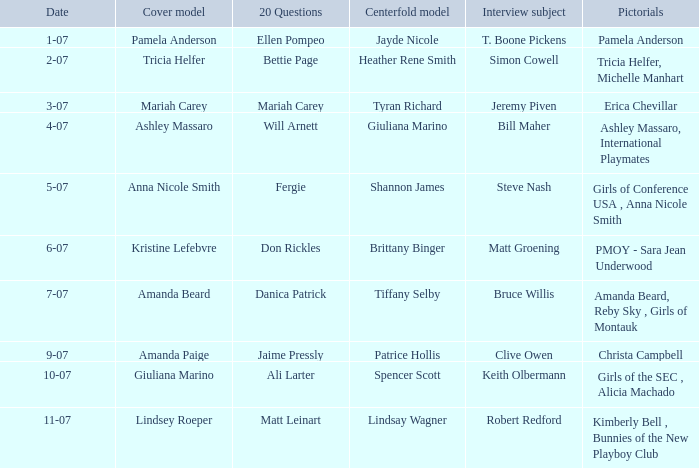Who answered the 20 questions on 10-07? Ali Larter. 